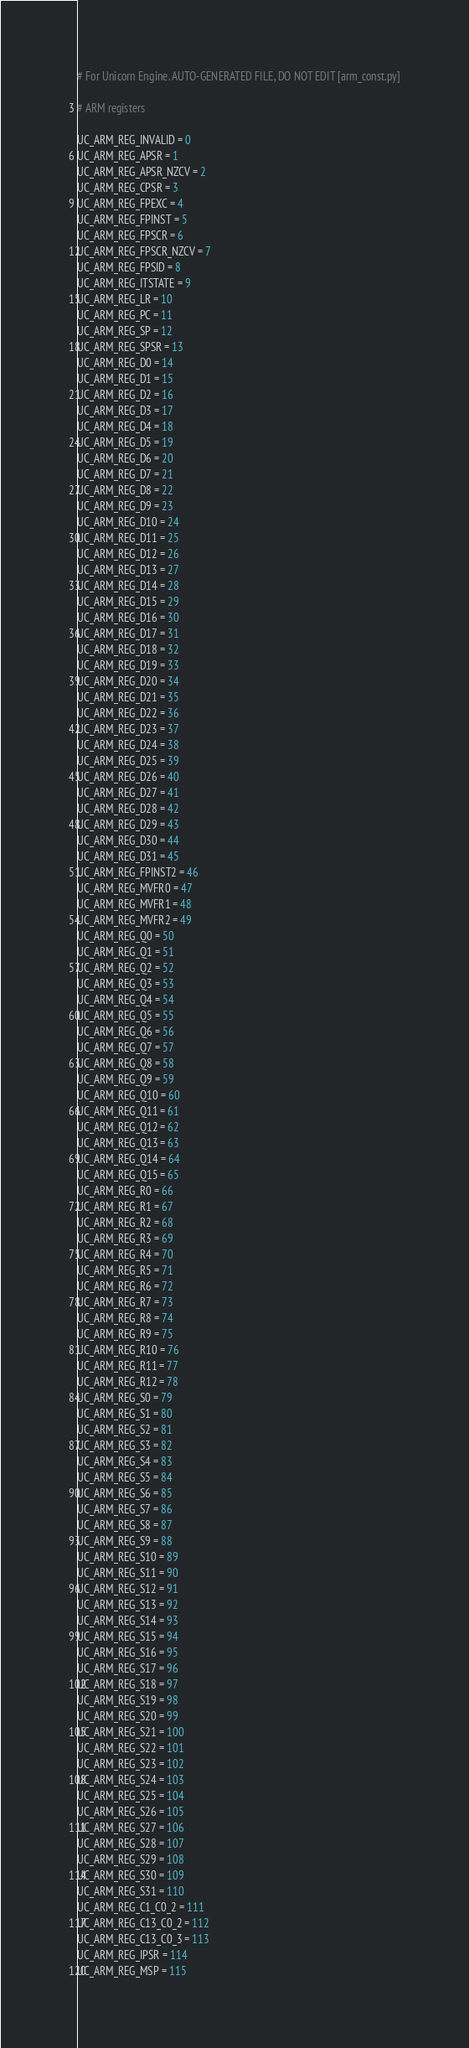<code> <loc_0><loc_0><loc_500><loc_500><_Python_># For Unicorn Engine. AUTO-GENERATED FILE, DO NOT EDIT [arm_const.py]

# ARM registers

UC_ARM_REG_INVALID = 0
UC_ARM_REG_APSR = 1
UC_ARM_REG_APSR_NZCV = 2
UC_ARM_REG_CPSR = 3
UC_ARM_REG_FPEXC = 4
UC_ARM_REG_FPINST = 5
UC_ARM_REG_FPSCR = 6
UC_ARM_REG_FPSCR_NZCV = 7
UC_ARM_REG_FPSID = 8
UC_ARM_REG_ITSTATE = 9
UC_ARM_REG_LR = 10
UC_ARM_REG_PC = 11
UC_ARM_REG_SP = 12
UC_ARM_REG_SPSR = 13
UC_ARM_REG_D0 = 14
UC_ARM_REG_D1 = 15
UC_ARM_REG_D2 = 16
UC_ARM_REG_D3 = 17
UC_ARM_REG_D4 = 18
UC_ARM_REG_D5 = 19
UC_ARM_REG_D6 = 20
UC_ARM_REG_D7 = 21
UC_ARM_REG_D8 = 22
UC_ARM_REG_D9 = 23
UC_ARM_REG_D10 = 24
UC_ARM_REG_D11 = 25
UC_ARM_REG_D12 = 26
UC_ARM_REG_D13 = 27
UC_ARM_REG_D14 = 28
UC_ARM_REG_D15 = 29
UC_ARM_REG_D16 = 30
UC_ARM_REG_D17 = 31
UC_ARM_REG_D18 = 32
UC_ARM_REG_D19 = 33
UC_ARM_REG_D20 = 34
UC_ARM_REG_D21 = 35
UC_ARM_REG_D22 = 36
UC_ARM_REG_D23 = 37
UC_ARM_REG_D24 = 38
UC_ARM_REG_D25 = 39
UC_ARM_REG_D26 = 40
UC_ARM_REG_D27 = 41
UC_ARM_REG_D28 = 42
UC_ARM_REG_D29 = 43
UC_ARM_REG_D30 = 44
UC_ARM_REG_D31 = 45
UC_ARM_REG_FPINST2 = 46
UC_ARM_REG_MVFR0 = 47
UC_ARM_REG_MVFR1 = 48
UC_ARM_REG_MVFR2 = 49
UC_ARM_REG_Q0 = 50
UC_ARM_REG_Q1 = 51
UC_ARM_REG_Q2 = 52
UC_ARM_REG_Q3 = 53
UC_ARM_REG_Q4 = 54
UC_ARM_REG_Q5 = 55
UC_ARM_REG_Q6 = 56
UC_ARM_REG_Q7 = 57
UC_ARM_REG_Q8 = 58
UC_ARM_REG_Q9 = 59
UC_ARM_REG_Q10 = 60
UC_ARM_REG_Q11 = 61
UC_ARM_REG_Q12 = 62
UC_ARM_REG_Q13 = 63
UC_ARM_REG_Q14 = 64
UC_ARM_REG_Q15 = 65
UC_ARM_REG_R0 = 66
UC_ARM_REG_R1 = 67
UC_ARM_REG_R2 = 68
UC_ARM_REG_R3 = 69
UC_ARM_REG_R4 = 70
UC_ARM_REG_R5 = 71
UC_ARM_REG_R6 = 72
UC_ARM_REG_R7 = 73
UC_ARM_REG_R8 = 74
UC_ARM_REG_R9 = 75
UC_ARM_REG_R10 = 76
UC_ARM_REG_R11 = 77
UC_ARM_REG_R12 = 78
UC_ARM_REG_S0 = 79
UC_ARM_REG_S1 = 80
UC_ARM_REG_S2 = 81
UC_ARM_REG_S3 = 82
UC_ARM_REG_S4 = 83
UC_ARM_REG_S5 = 84
UC_ARM_REG_S6 = 85
UC_ARM_REG_S7 = 86
UC_ARM_REG_S8 = 87
UC_ARM_REG_S9 = 88
UC_ARM_REG_S10 = 89
UC_ARM_REG_S11 = 90
UC_ARM_REG_S12 = 91
UC_ARM_REG_S13 = 92
UC_ARM_REG_S14 = 93
UC_ARM_REG_S15 = 94
UC_ARM_REG_S16 = 95
UC_ARM_REG_S17 = 96
UC_ARM_REG_S18 = 97
UC_ARM_REG_S19 = 98
UC_ARM_REG_S20 = 99
UC_ARM_REG_S21 = 100
UC_ARM_REG_S22 = 101
UC_ARM_REG_S23 = 102
UC_ARM_REG_S24 = 103
UC_ARM_REG_S25 = 104
UC_ARM_REG_S26 = 105
UC_ARM_REG_S27 = 106
UC_ARM_REG_S28 = 107
UC_ARM_REG_S29 = 108
UC_ARM_REG_S30 = 109
UC_ARM_REG_S31 = 110
UC_ARM_REG_C1_C0_2 = 111
UC_ARM_REG_C13_C0_2 = 112
UC_ARM_REG_C13_C0_3 = 113
UC_ARM_REG_IPSR = 114
UC_ARM_REG_MSP = 115</code> 